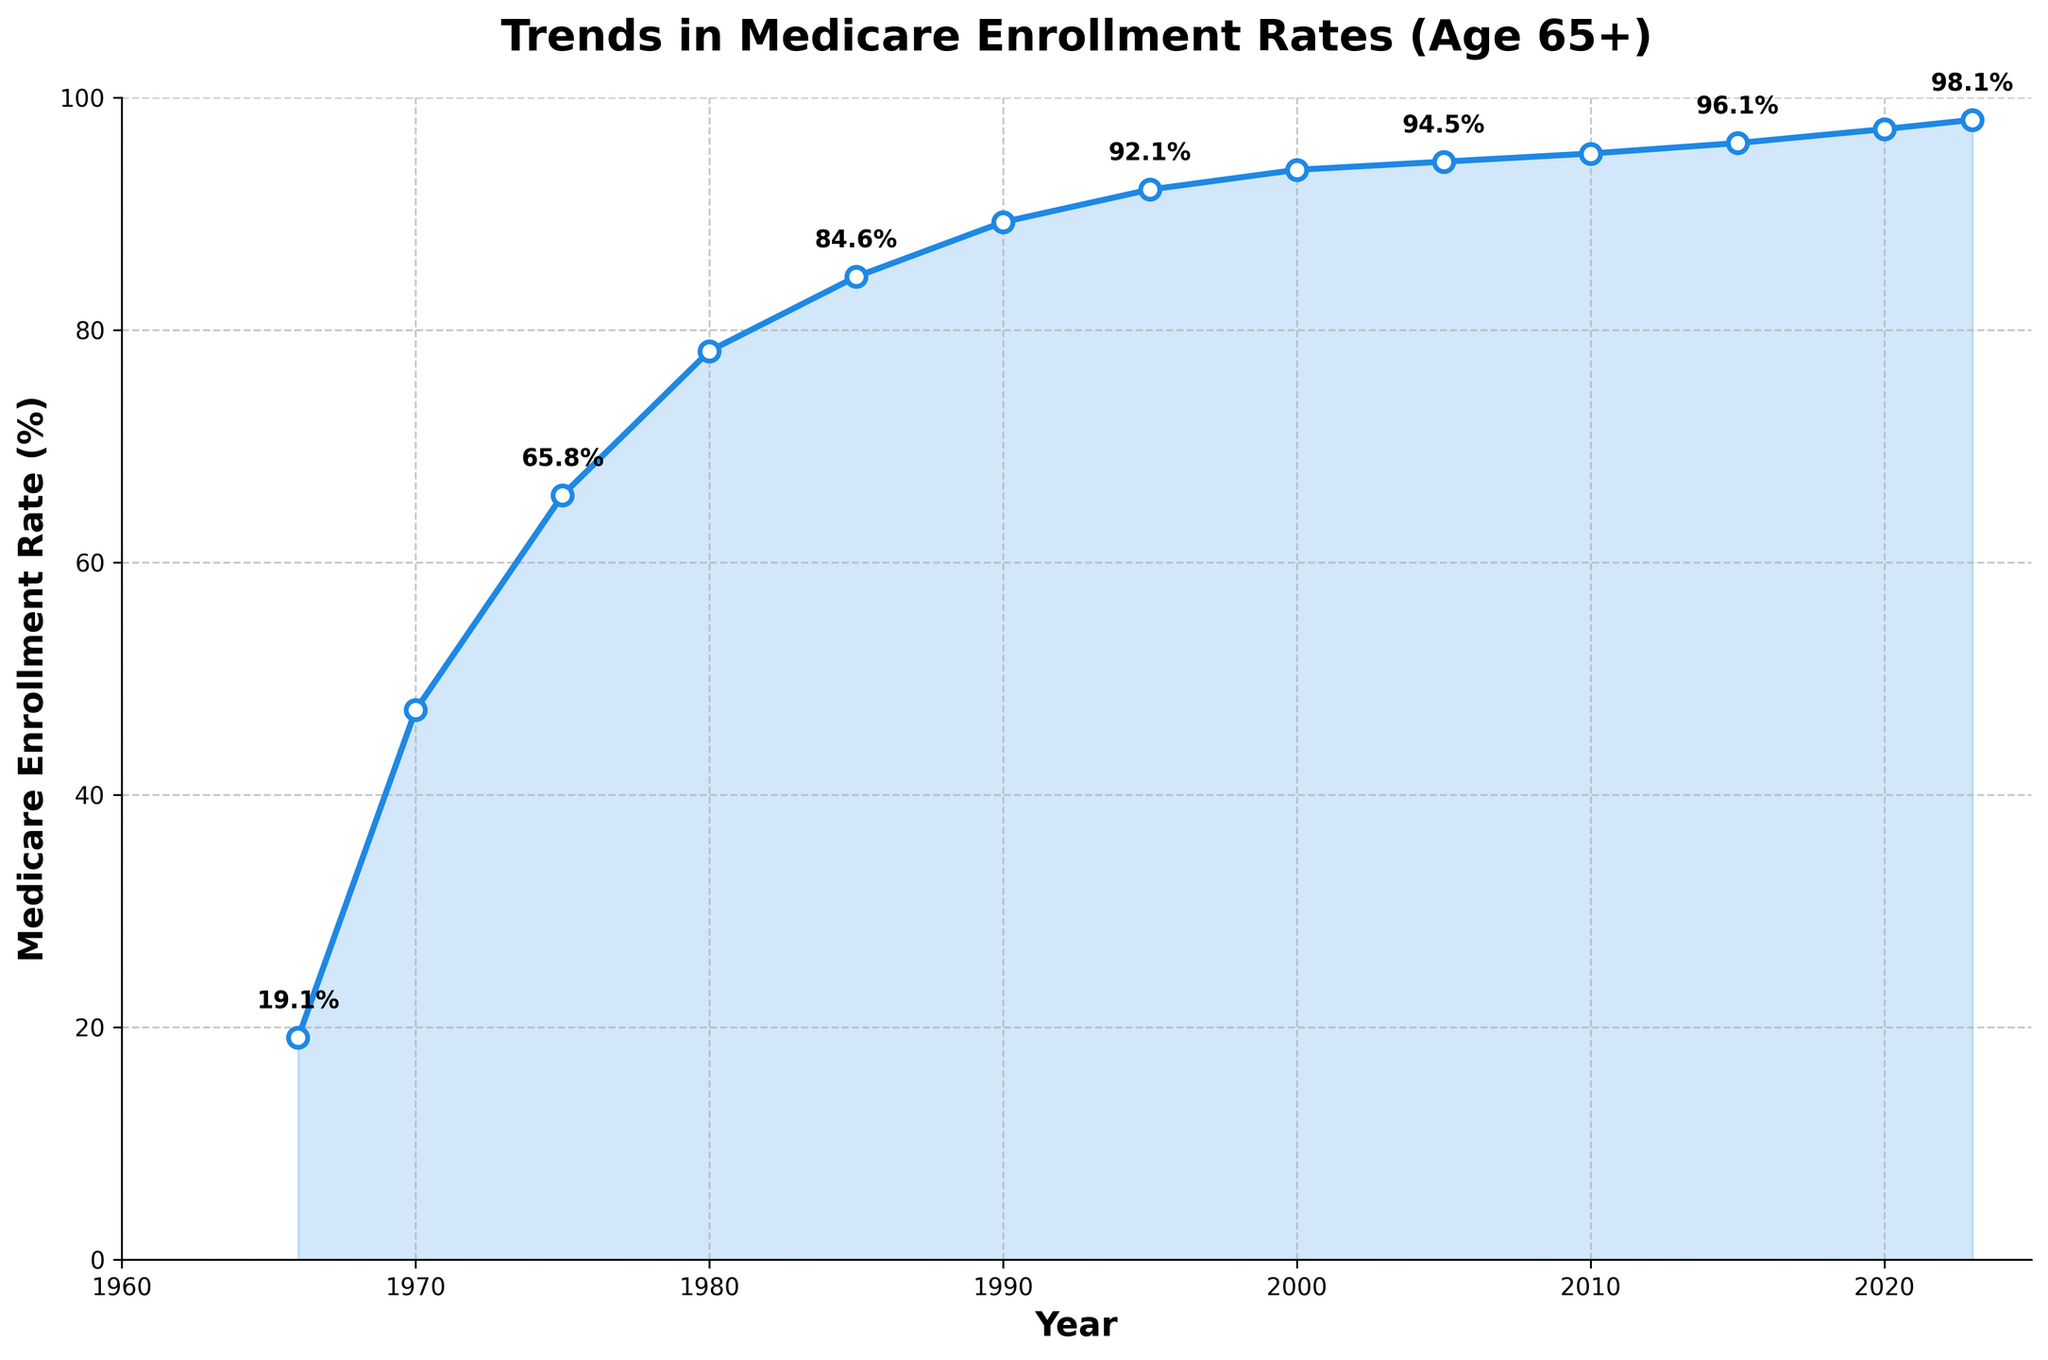What year had the lowest Medicare enrollment rate? The lowest enrollment rate is located at the beginning of the trend line. From the chart, it is noticeable that the year 1966 has the lowest enrollment rate at 19.1%.
Answer: 1966 How much did the Medicare enrollment rate increase from 1966 to 1970? To find the increase, subtract the rate in 1966 (19.1%) from the rate in 1970 (47.3%). The calculation is 47.3% - 19.1% = 28.2%.
Answer: 28.2% Between which consecutive five-year periods did Medicare enrollment rates change the most? Analyzing the differences between the enrollment rates over consecutive five-year periods reveals the following changes: 1970-1975 (65.8% - 47.3% = 18.5%), 1975-1980 (78.2% - 65.8% = 12.4%), etc. The most significant change is between 1966-1970 with a difference of 28.2%.
Answer: 1966-1970 By how many percentage points did Medicare enrollment increase from 1995 to 2023? Subtract the rate in 1995 (92.1%) from the rate in 2023 (98.1%). The calculation is 98.1% - 92.1% = 6%.
Answer: 6 What was the average Medicare enrollment rate between 2000 and 2020? The years to consider are 2000, 2005, 2010, 2015, and 2020. The rates are 93.8%, 94.5%, 95.2%, 96.1%, and 97.3% respectively. Calculate the average by summing these rates and dividing by 5. The sum is 477.9%, and the average is 477.9% / 5 = 95.58%.
Answer: 95.58% Which period saw the enrollment rate grow from under 50% to above 80%? From the chart, the enrollment rate crossed from under 50% to above 80% between 1970 (47.3%) and 1980 (78.2%). Taking into account the years, this growth period spanned from the early 1970s to early 1980s.
Answer: Early 1970s to Early 1980s What is the difference in Medicare enrollment rates between 1980 and 1990? Subtract the rate in 1980 (78.2%) from the rate in 1990 (89.3%). The calculation is 89.3% - 78.2% = 11.1%.
Answer: 11.1 When did the Medicare enrollment rate first surpass 90%? Observing the rates, the first time it surpassed 90% was in 1995 with a rate of 92.1%.
Answer: 1995 How many years did it take for the Medicare enrollment rate to reach 90%? The initial rate in 1966 was 19.1%. It first reached 90% in 1995. The number of years is 1995 - 1966, which equals 29 years.
Answer: 29 What can be said about the overall trend in Medicare enrollment rates over the years? The trend line displays a steady and significant increase in Medicare enrollment rates from 19.1% in 1966 to 98.1% in 2023, indicating persistent growth over time.
Answer: Steady increase 